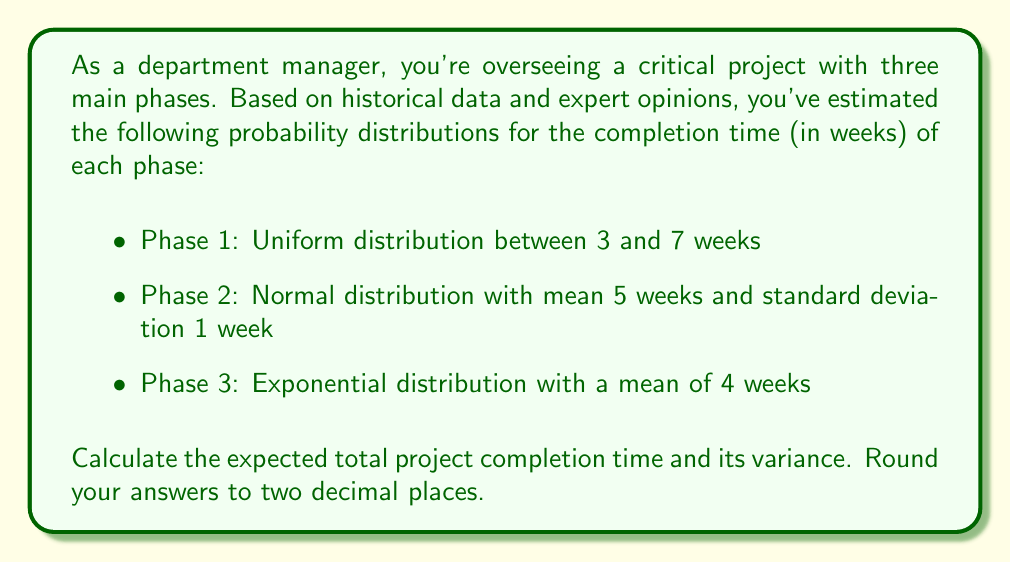Show me your answer to this math problem. To solve this problem, we need to calculate the expected value and variance for each phase, then combine them to get the total project completion time.

1. Phase 1 (Uniform distribution):
   Expected value: $E(X_1) = \frac{a+b}{2} = \frac{3+7}{2} = 5$ weeks
   Variance: $Var(X_1) = \frac{(b-a)^2}{12} = \frac{(7-3)^2}{12} = \frac{16}{12} = \frac{4}{3}$ weeks²

2. Phase 2 (Normal distribution):
   Expected value: $E(X_2) = \mu = 5$ weeks
   Variance: $Var(X_2) = \sigma^2 = 1^2 = 1$ week²

3. Phase 3 (Exponential distribution):
   Expected value: $E(X_3) = \lambda^{-1} = 4$ weeks
   Variance: $Var(X_3) = \lambda^{-2} = 4^2 = 16$ weeks²

Now, let's calculate the total expected project completion time:
$$E(X_{total}) = E(X_1) + E(X_2) + E(X_3) = 5 + 5 + 4 = 14$$ weeks

For the variance, since the phases are independent, we can sum the individual variances:
$$Var(X_{total}) = Var(X_1) + Var(X_2) + Var(X_3) = \frac{4}{3} + 1 + 16 = \frac{4}{3} + \frac{3}{3} + \frac{48}{3} = \frac{55}{3} = 18.33$$ weeks²

Rounding to two decimal places:
Expected total project completion time: 14.00 weeks
Variance of total project completion time: 18.33 weeks²
Answer: Expected total project completion time: 14.00 weeks
Variance of total project completion time: 18.33 weeks² 